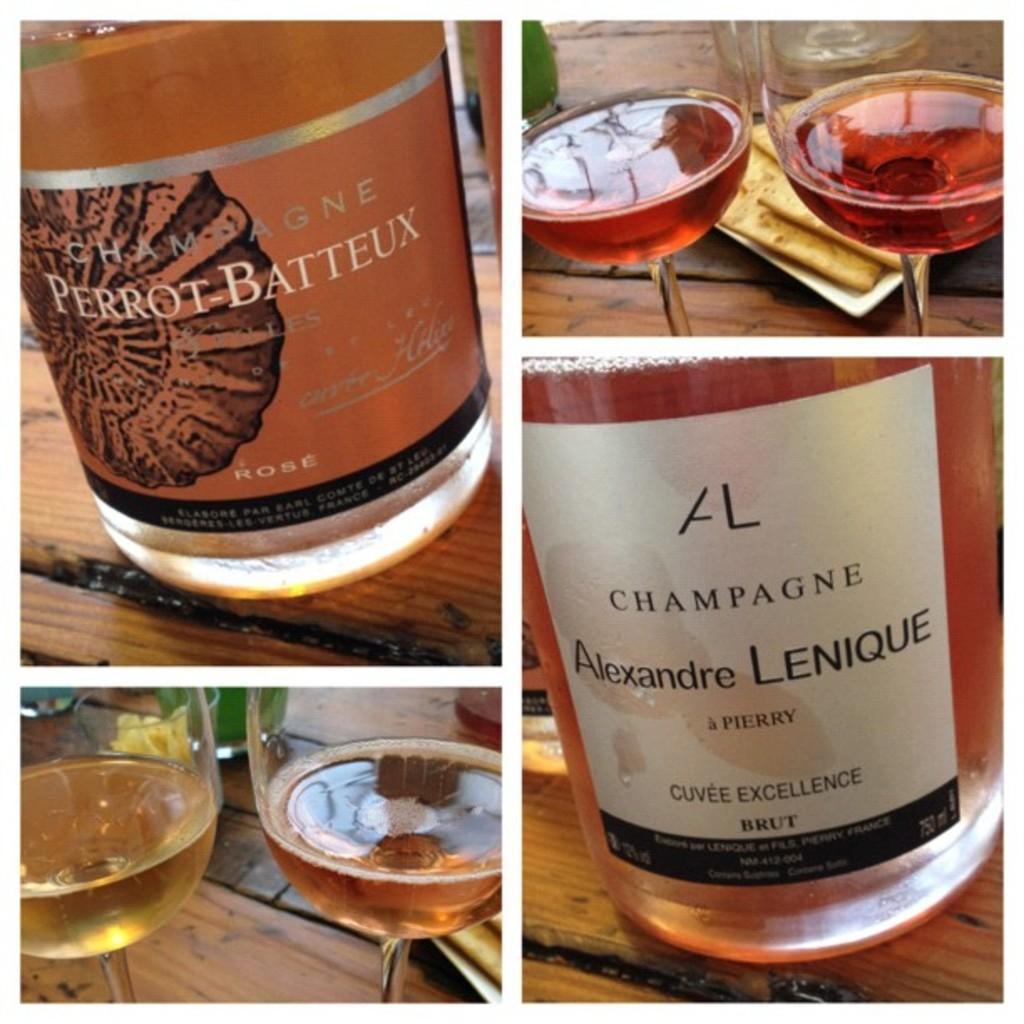<image>
Write a terse but informative summary of the picture. Two bottles of champagne are called "PERROT BATTEUX" and "Alexandre LENIQUE". 